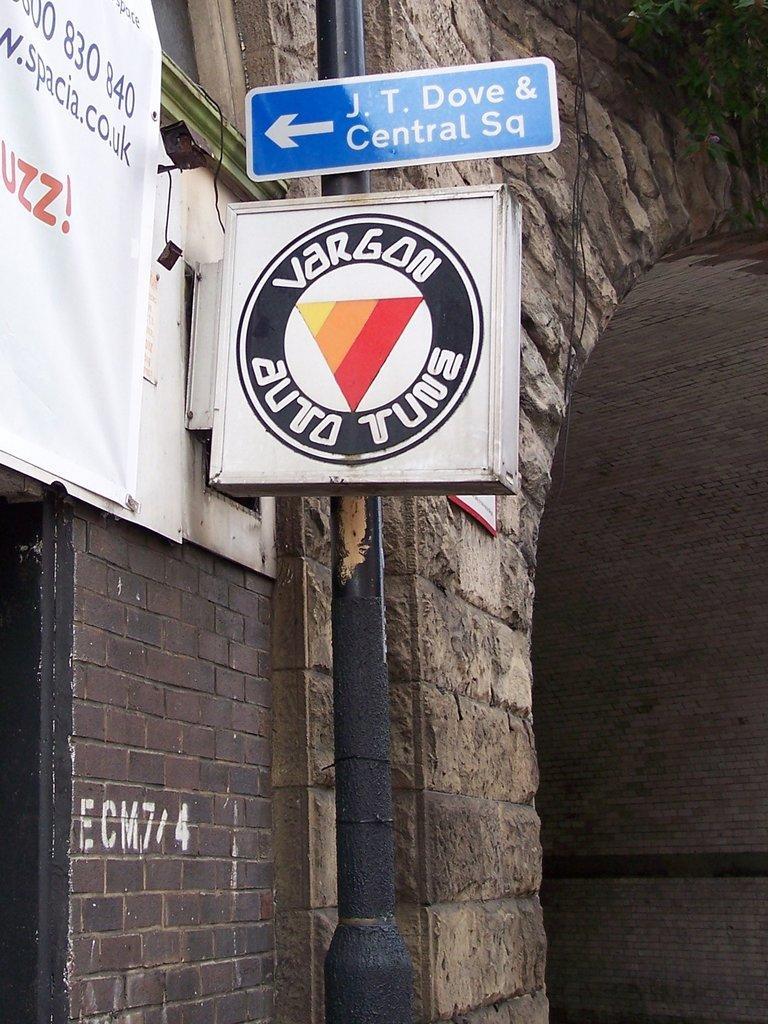Please provide a concise description of this image. In the image I can see a pole which has boards attached to it. On boards I can see logo and something written on it. I can also see a wall which has some objects attached to it. 